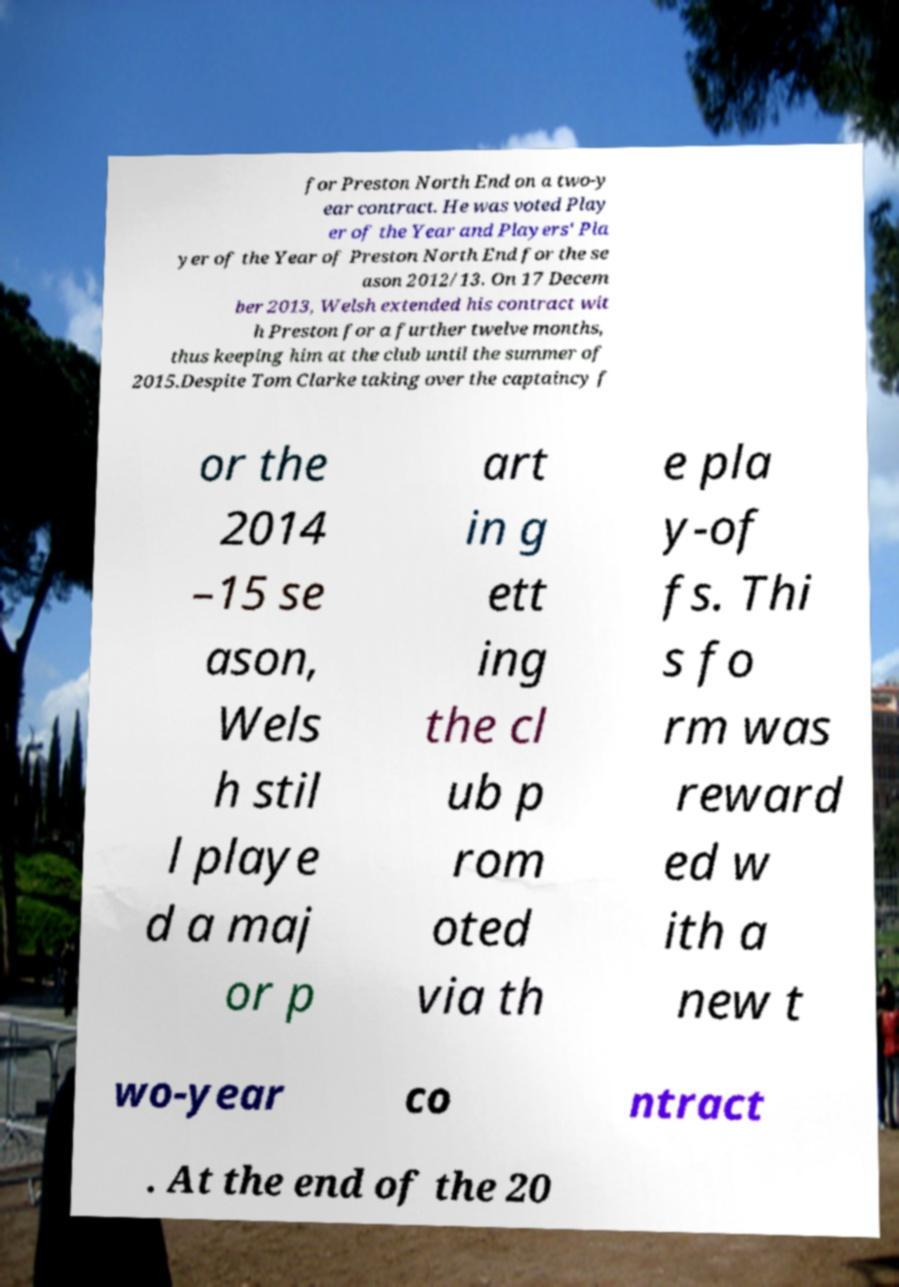Could you extract and type out the text from this image? for Preston North End on a two-y ear contract. He was voted Play er of the Year and Players' Pla yer of the Year of Preston North End for the se ason 2012/13. On 17 Decem ber 2013, Welsh extended his contract wit h Preston for a further twelve months, thus keeping him at the club until the summer of 2015.Despite Tom Clarke taking over the captaincy f or the 2014 –15 se ason, Wels h stil l playe d a maj or p art in g ett ing the cl ub p rom oted via th e pla y-of fs. Thi s fo rm was reward ed w ith a new t wo-year co ntract . At the end of the 20 